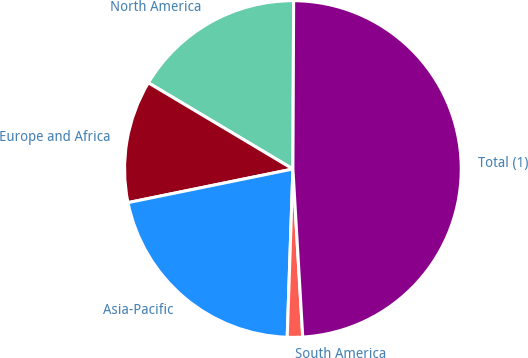Convert chart to OTSL. <chart><loc_0><loc_0><loc_500><loc_500><pie_chart><fcel>North America<fcel>Europe and Africa<fcel>Asia-Pacific<fcel>South America<fcel>Total (1)<nl><fcel>16.51%<fcel>11.76%<fcel>21.26%<fcel>1.47%<fcel>49.0%<nl></chart> 